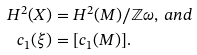Convert formula to latex. <formula><loc_0><loc_0><loc_500><loc_500>H ^ { 2 } ( X ) & = H ^ { 2 } ( M ) / \mathbb { Z } \omega , \, a n d \\ c _ { 1 } ( \xi ) & = [ c _ { 1 } ( M ) ] .</formula> 